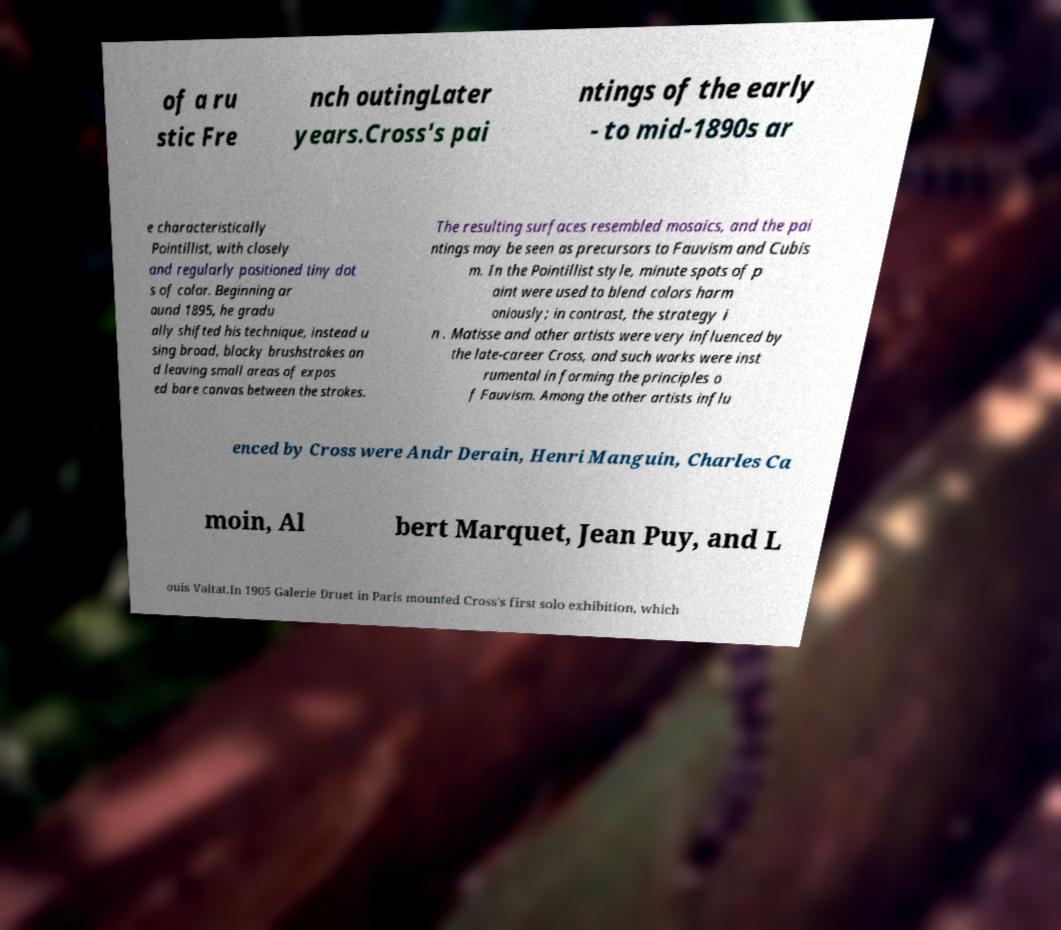I need the written content from this picture converted into text. Can you do that? of a ru stic Fre nch outingLater years.Cross's pai ntings of the early - to mid-1890s ar e characteristically Pointillist, with closely and regularly positioned tiny dot s of color. Beginning ar ound 1895, he gradu ally shifted his technique, instead u sing broad, blocky brushstrokes an d leaving small areas of expos ed bare canvas between the strokes. The resulting surfaces resembled mosaics, and the pai ntings may be seen as precursors to Fauvism and Cubis m. In the Pointillist style, minute spots of p aint were used to blend colors harm oniously; in contrast, the strategy i n . Matisse and other artists were very influenced by the late-career Cross, and such works were inst rumental in forming the principles o f Fauvism. Among the other artists influ enced by Cross were Andr Derain, Henri Manguin, Charles Ca moin, Al bert Marquet, Jean Puy, and L ouis Valtat.In 1905 Galerie Druet in Paris mounted Cross's first solo exhibition, which 